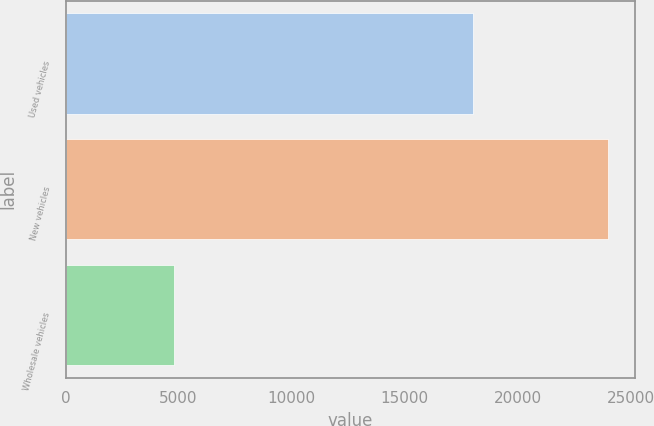<chart> <loc_0><loc_0><loc_500><loc_500><bar_chart><fcel>Used vehicles<fcel>New vehicles<fcel>Wholesale vehicles<nl><fcel>18019<fcel>23989<fcel>4816<nl></chart> 